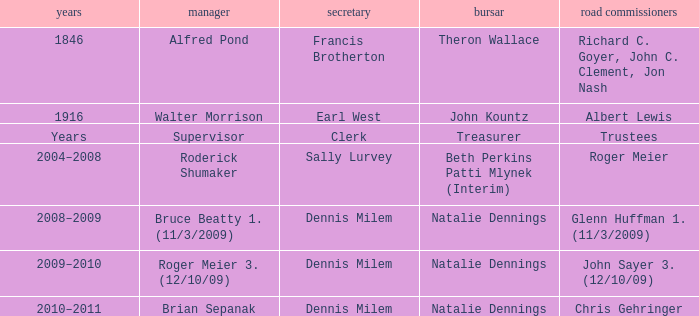Who was the supervisor in the year 1846? Alfred Pond. 